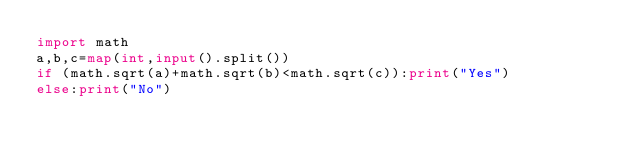<code> <loc_0><loc_0><loc_500><loc_500><_Python_>import math
a,b,c=map(int,input().split())
if (math.sqrt(a)+math.sqrt(b)<math.sqrt(c)):print("Yes")
else:print("No")</code> 